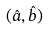<formula> <loc_0><loc_0><loc_500><loc_500>( { \hat { a } } , { \hat { b } } )</formula> 